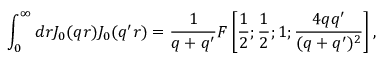Convert formula to latex. <formula><loc_0><loc_0><loc_500><loc_500>\int _ { 0 } ^ { \infty } d r J _ { 0 } ( q r ) J _ { 0 } ( q ^ { \prime } r ) = \frac { 1 } q + q ^ { \prime } } F \left [ \frac { 1 } 2 } ; \frac { 1 } 2 } ; 1 ; \frac { 4 q q ^ { \prime } } { ( q + q ^ { \prime } ) ^ { 2 } } \right ] ,</formula> 